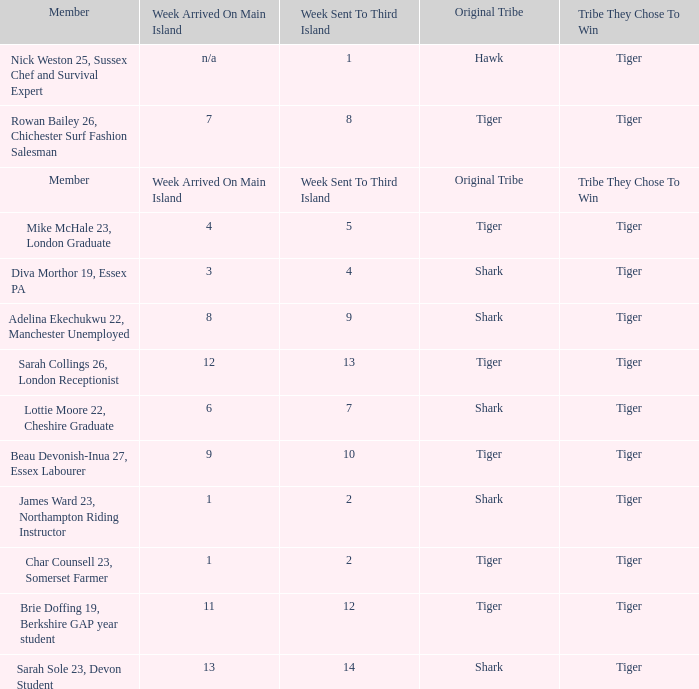Can you give me this table as a dict? {'header': ['Member', 'Week Arrived On Main Island', 'Week Sent To Third Island', 'Original Tribe', 'Tribe They Chose To Win'], 'rows': [['Nick Weston 25, Sussex Chef and Survival Expert', 'n/a', '1', 'Hawk', 'Tiger'], ['Rowan Bailey 26, Chichester Surf Fashion Salesman', '7', '8', 'Tiger', 'Tiger'], ['Member', 'Week Arrived On Main Island', 'Week Sent To Third Island', 'Original Tribe', 'Tribe They Chose To Win'], ['Mike McHale 23, London Graduate', '4', '5', 'Tiger', 'Tiger'], ['Diva Morthor 19, Essex PA', '3', '4', 'Shark', 'Tiger'], ['Adelina Ekechukwu 22, Manchester Unemployed', '8', '9', 'Shark', 'Tiger'], ['Sarah Collings 26, London Receptionist', '12', '13', 'Tiger', 'Tiger'], ['Lottie Moore 22, Cheshire Graduate', '6', '7', 'Shark', 'Tiger'], ['Beau Devonish-Inua 27, Essex Labourer', '9', '10', 'Tiger', 'Tiger'], ['James Ward 23, Northampton Riding Instructor', '1', '2', 'Shark', 'Tiger'], ['Char Counsell 23, Somerset Farmer', '1', '2', 'Tiger', 'Tiger'], ['Brie Doffing 19, Berkshire GAP year student', '11', '12', 'Tiger', 'Tiger'], ['Sarah Sole 23, Devon Student', '13', '14', 'Shark', 'Tiger']]} How many members arrived on the main island in week 4? 1.0. 